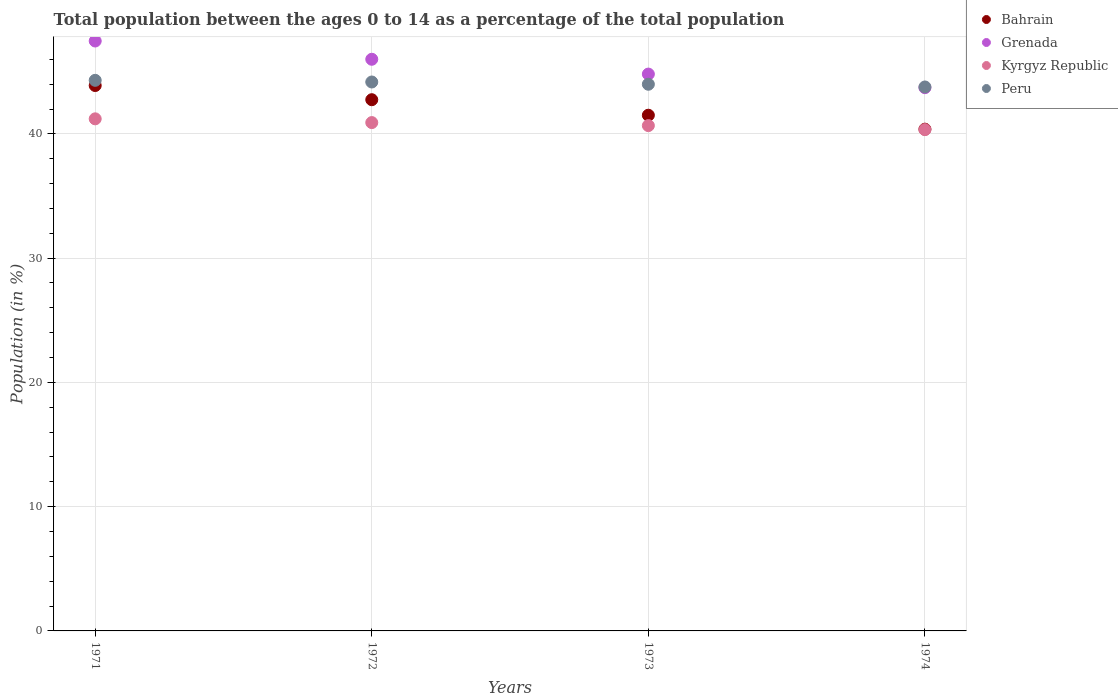Is the number of dotlines equal to the number of legend labels?
Your answer should be compact. Yes. What is the percentage of the population ages 0 to 14 in Peru in 1974?
Your response must be concise. 43.78. Across all years, what is the maximum percentage of the population ages 0 to 14 in Bahrain?
Provide a succinct answer. 43.89. Across all years, what is the minimum percentage of the population ages 0 to 14 in Kyrgyz Republic?
Your response must be concise. 40.34. In which year was the percentage of the population ages 0 to 14 in Peru maximum?
Your answer should be very brief. 1971. In which year was the percentage of the population ages 0 to 14 in Grenada minimum?
Your answer should be very brief. 1974. What is the total percentage of the population ages 0 to 14 in Kyrgyz Republic in the graph?
Ensure brevity in your answer.  163.13. What is the difference between the percentage of the population ages 0 to 14 in Bahrain in 1971 and that in 1974?
Your answer should be compact. 3.51. What is the difference between the percentage of the population ages 0 to 14 in Peru in 1972 and the percentage of the population ages 0 to 14 in Grenada in 1974?
Give a very brief answer. 0.46. What is the average percentage of the population ages 0 to 14 in Grenada per year?
Keep it short and to the point. 45.5. In the year 1972, what is the difference between the percentage of the population ages 0 to 14 in Kyrgyz Republic and percentage of the population ages 0 to 14 in Grenada?
Provide a short and direct response. -5.1. What is the ratio of the percentage of the population ages 0 to 14 in Grenada in 1972 to that in 1974?
Make the answer very short. 1.05. Is the difference between the percentage of the population ages 0 to 14 in Kyrgyz Republic in 1971 and 1973 greater than the difference between the percentage of the population ages 0 to 14 in Grenada in 1971 and 1973?
Your answer should be compact. No. What is the difference between the highest and the second highest percentage of the population ages 0 to 14 in Bahrain?
Your response must be concise. 1.14. What is the difference between the highest and the lowest percentage of the population ages 0 to 14 in Bahrain?
Offer a very short reply. 3.51. In how many years, is the percentage of the population ages 0 to 14 in Bahrain greater than the average percentage of the population ages 0 to 14 in Bahrain taken over all years?
Provide a short and direct response. 2. Is the sum of the percentage of the population ages 0 to 14 in Peru in 1971 and 1973 greater than the maximum percentage of the population ages 0 to 14 in Kyrgyz Republic across all years?
Offer a terse response. Yes. Is it the case that in every year, the sum of the percentage of the population ages 0 to 14 in Grenada and percentage of the population ages 0 to 14 in Kyrgyz Republic  is greater than the sum of percentage of the population ages 0 to 14 in Bahrain and percentage of the population ages 0 to 14 in Peru?
Your answer should be compact. No. Is it the case that in every year, the sum of the percentage of the population ages 0 to 14 in Peru and percentage of the population ages 0 to 14 in Grenada  is greater than the percentage of the population ages 0 to 14 in Bahrain?
Keep it short and to the point. Yes. How many dotlines are there?
Keep it short and to the point. 4. How many years are there in the graph?
Your response must be concise. 4. Are the values on the major ticks of Y-axis written in scientific E-notation?
Keep it short and to the point. No. Does the graph contain any zero values?
Your response must be concise. No. Does the graph contain grids?
Offer a very short reply. Yes. Where does the legend appear in the graph?
Keep it short and to the point. Top right. How many legend labels are there?
Your answer should be very brief. 4. How are the legend labels stacked?
Ensure brevity in your answer.  Vertical. What is the title of the graph?
Offer a terse response. Total population between the ages 0 to 14 as a percentage of the total population. What is the label or title of the Y-axis?
Offer a terse response. Population (in %). What is the Population (in %) of Bahrain in 1971?
Provide a succinct answer. 43.89. What is the Population (in %) in Grenada in 1971?
Your response must be concise. 47.48. What is the Population (in %) in Kyrgyz Republic in 1971?
Give a very brief answer. 41.21. What is the Population (in %) of Peru in 1971?
Your response must be concise. 44.31. What is the Population (in %) in Bahrain in 1972?
Your answer should be compact. 42.75. What is the Population (in %) in Grenada in 1972?
Keep it short and to the point. 46.01. What is the Population (in %) in Kyrgyz Republic in 1972?
Your answer should be very brief. 40.91. What is the Population (in %) of Peru in 1972?
Give a very brief answer. 44.18. What is the Population (in %) in Bahrain in 1973?
Give a very brief answer. 41.5. What is the Population (in %) of Grenada in 1973?
Provide a succinct answer. 44.81. What is the Population (in %) of Kyrgyz Republic in 1973?
Give a very brief answer. 40.67. What is the Population (in %) in Peru in 1973?
Your response must be concise. 44. What is the Population (in %) of Bahrain in 1974?
Your response must be concise. 40.38. What is the Population (in %) of Grenada in 1974?
Your answer should be very brief. 43.72. What is the Population (in %) in Kyrgyz Republic in 1974?
Ensure brevity in your answer.  40.34. What is the Population (in %) in Peru in 1974?
Your answer should be compact. 43.78. Across all years, what is the maximum Population (in %) in Bahrain?
Make the answer very short. 43.89. Across all years, what is the maximum Population (in %) of Grenada?
Ensure brevity in your answer.  47.48. Across all years, what is the maximum Population (in %) in Kyrgyz Republic?
Provide a succinct answer. 41.21. Across all years, what is the maximum Population (in %) in Peru?
Provide a succinct answer. 44.31. Across all years, what is the minimum Population (in %) in Bahrain?
Offer a terse response. 40.38. Across all years, what is the minimum Population (in %) in Grenada?
Make the answer very short. 43.72. Across all years, what is the minimum Population (in %) of Kyrgyz Republic?
Your answer should be compact. 40.34. Across all years, what is the minimum Population (in %) in Peru?
Ensure brevity in your answer.  43.78. What is the total Population (in %) of Bahrain in the graph?
Your response must be concise. 168.53. What is the total Population (in %) of Grenada in the graph?
Keep it short and to the point. 182.01. What is the total Population (in %) in Kyrgyz Republic in the graph?
Provide a short and direct response. 163.13. What is the total Population (in %) in Peru in the graph?
Your answer should be very brief. 176.26. What is the difference between the Population (in %) in Bahrain in 1971 and that in 1972?
Ensure brevity in your answer.  1.14. What is the difference between the Population (in %) in Grenada in 1971 and that in 1972?
Offer a terse response. 1.47. What is the difference between the Population (in %) in Kyrgyz Republic in 1971 and that in 1972?
Provide a short and direct response. 0.3. What is the difference between the Population (in %) of Peru in 1971 and that in 1972?
Make the answer very short. 0.13. What is the difference between the Population (in %) in Bahrain in 1971 and that in 1973?
Your answer should be compact. 2.39. What is the difference between the Population (in %) in Grenada in 1971 and that in 1973?
Provide a succinct answer. 2.66. What is the difference between the Population (in %) in Kyrgyz Republic in 1971 and that in 1973?
Keep it short and to the point. 0.54. What is the difference between the Population (in %) of Peru in 1971 and that in 1973?
Keep it short and to the point. 0.31. What is the difference between the Population (in %) in Bahrain in 1971 and that in 1974?
Provide a short and direct response. 3.51. What is the difference between the Population (in %) in Grenada in 1971 and that in 1974?
Provide a short and direct response. 3.76. What is the difference between the Population (in %) of Kyrgyz Republic in 1971 and that in 1974?
Keep it short and to the point. 0.87. What is the difference between the Population (in %) in Peru in 1971 and that in 1974?
Make the answer very short. 0.53. What is the difference between the Population (in %) of Bahrain in 1972 and that in 1973?
Give a very brief answer. 1.25. What is the difference between the Population (in %) in Grenada in 1972 and that in 1973?
Your answer should be compact. 1.19. What is the difference between the Population (in %) in Kyrgyz Republic in 1972 and that in 1973?
Offer a terse response. 0.24. What is the difference between the Population (in %) of Peru in 1972 and that in 1973?
Offer a terse response. 0.18. What is the difference between the Population (in %) in Bahrain in 1972 and that in 1974?
Keep it short and to the point. 2.37. What is the difference between the Population (in %) of Grenada in 1972 and that in 1974?
Ensure brevity in your answer.  2.29. What is the difference between the Population (in %) in Kyrgyz Republic in 1972 and that in 1974?
Give a very brief answer. 0.57. What is the difference between the Population (in %) in Peru in 1972 and that in 1974?
Provide a short and direct response. 0.4. What is the difference between the Population (in %) of Bahrain in 1973 and that in 1974?
Give a very brief answer. 1.12. What is the difference between the Population (in %) of Grenada in 1973 and that in 1974?
Provide a short and direct response. 1.09. What is the difference between the Population (in %) of Kyrgyz Republic in 1973 and that in 1974?
Your response must be concise. 0.32. What is the difference between the Population (in %) in Peru in 1973 and that in 1974?
Your answer should be compact. 0.22. What is the difference between the Population (in %) of Bahrain in 1971 and the Population (in %) of Grenada in 1972?
Your answer should be very brief. -2.11. What is the difference between the Population (in %) in Bahrain in 1971 and the Population (in %) in Kyrgyz Republic in 1972?
Keep it short and to the point. 2.98. What is the difference between the Population (in %) in Bahrain in 1971 and the Population (in %) in Peru in 1972?
Provide a succinct answer. -0.28. What is the difference between the Population (in %) of Grenada in 1971 and the Population (in %) of Kyrgyz Republic in 1972?
Give a very brief answer. 6.57. What is the difference between the Population (in %) of Grenada in 1971 and the Population (in %) of Peru in 1972?
Keep it short and to the point. 3.3. What is the difference between the Population (in %) of Kyrgyz Republic in 1971 and the Population (in %) of Peru in 1972?
Your answer should be compact. -2.96. What is the difference between the Population (in %) of Bahrain in 1971 and the Population (in %) of Grenada in 1973?
Ensure brevity in your answer.  -0.92. What is the difference between the Population (in %) in Bahrain in 1971 and the Population (in %) in Kyrgyz Republic in 1973?
Offer a terse response. 3.22. What is the difference between the Population (in %) in Bahrain in 1971 and the Population (in %) in Peru in 1973?
Offer a terse response. -0.1. What is the difference between the Population (in %) of Grenada in 1971 and the Population (in %) of Kyrgyz Republic in 1973?
Give a very brief answer. 6.81. What is the difference between the Population (in %) of Grenada in 1971 and the Population (in %) of Peru in 1973?
Your response must be concise. 3.48. What is the difference between the Population (in %) of Kyrgyz Republic in 1971 and the Population (in %) of Peru in 1973?
Offer a very short reply. -2.78. What is the difference between the Population (in %) in Bahrain in 1971 and the Population (in %) in Grenada in 1974?
Keep it short and to the point. 0.17. What is the difference between the Population (in %) of Bahrain in 1971 and the Population (in %) of Kyrgyz Republic in 1974?
Make the answer very short. 3.55. What is the difference between the Population (in %) of Bahrain in 1971 and the Population (in %) of Peru in 1974?
Give a very brief answer. 0.12. What is the difference between the Population (in %) in Grenada in 1971 and the Population (in %) in Kyrgyz Republic in 1974?
Your answer should be very brief. 7.13. What is the difference between the Population (in %) of Grenada in 1971 and the Population (in %) of Peru in 1974?
Keep it short and to the point. 3.7. What is the difference between the Population (in %) of Kyrgyz Republic in 1971 and the Population (in %) of Peru in 1974?
Ensure brevity in your answer.  -2.57. What is the difference between the Population (in %) in Bahrain in 1972 and the Population (in %) in Grenada in 1973?
Make the answer very short. -2.06. What is the difference between the Population (in %) in Bahrain in 1972 and the Population (in %) in Kyrgyz Republic in 1973?
Your answer should be compact. 2.08. What is the difference between the Population (in %) of Bahrain in 1972 and the Population (in %) of Peru in 1973?
Provide a short and direct response. -1.24. What is the difference between the Population (in %) of Grenada in 1972 and the Population (in %) of Kyrgyz Republic in 1973?
Ensure brevity in your answer.  5.34. What is the difference between the Population (in %) of Grenada in 1972 and the Population (in %) of Peru in 1973?
Offer a terse response. 2.01. What is the difference between the Population (in %) of Kyrgyz Republic in 1972 and the Population (in %) of Peru in 1973?
Your answer should be compact. -3.09. What is the difference between the Population (in %) of Bahrain in 1972 and the Population (in %) of Grenada in 1974?
Provide a succinct answer. -0.97. What is the difference between the Population (in %) of Bahrain in 1972 and the Population (in %) of Kyrgyz Republic in 1974?
Ensure brevity in your answer.  2.41. What is the difference between the Population (in %) of Bahrain in 1972 and the Population (in %) of Peru in 1974?
Offer a terse response. -1.03. What is the difference between the Population (in %) in Grenada in 1972 and the Population (in %) in Kyrgyz Republic in 1974?
Keep it short and to the point. 5.66. What is the difference between the Population (in %) in Grenada in 1972 and the Population (in %) in Peru in 1974?
Offer a terse response. 2.23. What is the difference between the Population (in %) of Kyrgyz Republic in 1972 and the Population (in %) of Peru in 1974?
Provide a short and direct response. -2.87. What is the difference between the Population (in %) in Bahrain in 1973 and the Population (in %) in Grenada in 1974?
Your answer should be very brief. -2.22. What is the difference between the Population (in %) in Bahrain in 1973 and the Population (in %) in Kyrgyz Republic in 1974?
Give a very brief answer. 1.16. What is the difference between the Population (in %) of Bahrain in 1973 and the Population (in %) of Peru in 1974?
Provide a succinct answer. -2.27. What is the difference between the Population (in %) in Grenada in 1973 and the Population (in %) in Kyrgyz Republic in 1974?
Offer a terse response. 4.47. What is the difference between the Population (in %) in Grenada in 1973 and the Population (in %) in Peru in 1974?
Offer a very short reply. 1.04. What is the difference between the Population (in %) in Kyrgyz Republic in 1973 and the Population (in %) in Peru in 1974?
Your answer should be very brief. -3.11. What is the average Population (in %) in Bahrain per year?
Give a very brief answer. 42.13. What is the average Population (in %) in Grenada per year?
Your response must be concise. 45.5. What is the average Population (in %) in Kyrgyz Republic per year?
Offer a very short reply. 40.78. What is the average Population (in %) of Peru per year?
Give a very brief answer. 44.06. In the year 1971, what is the difference between the Population (in %) of Bahrain and Population (in %) of Grenada?
Offer a very short reply. -3.58. In the year 1971, what is the difference between the Population (in %) of Bahrain and Population (in %) of Kyrgyz Republic?
Give a very brief answer. 2.68. In the year 1971, what is the difference between the Population (in %) of Bahrain and Population (in %) of Peru?
Provide a short and direct response. -0.42. In the year 1971, what is the difference between the Population (in %) of Grenada and Population (in %) of Kyrgyz Republic?
Provide a short and direct response. 6.26. In the year 1971, what is the difference between the Population (in %) in Grenada and Population (in %) in Peru?
Provide a short and direct response. 3.16. In the year 1971, what is the difference between the Population (in %) of Kyrgyz Republic and Population (in %) of Peru?
Give a very brief answer. -3.1. In the year 1972, what is the difference between the Population (in %) of Bahrain and Population (in %) of Grenada?
Make the answer very short. -3.25. In the year 1972, what is the difference between the Population (in %) of Bahrain and Population (in %) of Kyrgyz Republic?
Your response must be concise. 1.84. In the year 1972, what is the difference between the Population (in %) in Bahrain and Population (in %) in Peru?
Provide a succinct answer. -1.43. In the year 1972, what is the difference between the Population (in %) in Grenada and Population (in %) in Kyrgyz Republic?
Keep it short and to the point. 5.1. In the year 1972, what is the difference between the Population (in %) of Grenada and Population (in %) of Peru?
Offer a terse response. 1.83. In the year 1972, what is the difference between the Population (in %) in Kyrgyz Republic and Population (in %) in Peru?
Provide a succinct answer. -3.27. In the year 1973, what is the difference between the Population (in %) of Bahrain and Population (in %) of Grenada?
Ensure brevity in your answer.  -3.31. In the year 1973, what is the difference between the Population (in %) in Bahrain and Population (in %) in Kyrgyz Republic?
Offer a very short reply. 0.84. In the year 1973, what is the difference between the Population (in %) of Bahrain and Population (in %) of Peru?
Offer a terse response. -2.49. In the year 1973, what is the difference between the Population (in %) in Grenada and Population (in %) in Kyrgyz Republic?
Offer a terse response. 4.15. In the year 1973, what is the difference between the Population (in %) of Grenada and Population (in %) of Peru?
Ensure brevity in your answer.  0.82. In the year 1973, what is the difference between the Population (in %) of Kyrgyz Republic and Population (in %) of Peru?
Make the answer very short. -3.33. In the year 1974, what is the difference between the Population (in %) of Bahrain and Population (in %) of Grenada?
Keep it short and to the point. -3.34. In the year 1974, what is the difference between the Population (in %) of Bahrain and Population (in %) of Kyrgyz Republic?
Your response must be concise. 0.04. In the year 1974, what is the difference between the Population (in %) in Bahrain and Population (in %) in Peru?
Your answer should be compact. -3.4. In the year 1974, what is the difference between the Population (in %) in Grenada and Population (in %) in Kyrgyz Republic?
Keep it short and to the point. 3.38. In the year 1974, what is the difference between the Population (in %) in Grenada and Population (in %) in Peru?
Provide a short and direct response. -0.06. In the year 1974, what is the difference between the Population (in %) of Kyrgyz Republic and Population (in %) of Peru?
Provide a succinct answer. -3.43. What is the ratio of the Population (in %) of Bahrain in 1971 to that in 1972?
Ensure brevity in your answer.  1.03. What is the ratio of the Population (in %) of Grenada in 1971 to that in 1972?
Ensure brevity in your answer.  1.03. What is the ratio of the Population (in %) in Kyrgyz Republic in 1971 to that in 1972?
Your response must be concise. 1.01. What is the ratio of the Population (in %) in Bahrain in 1971 to that in 1973?
Offer a very short reply. 1.06. What is the ratio of the Population (in %) of Grenada in 1971 to that in 1973?
Your response must be concise. 1.06. What is the ratio of the Population (in %) of Kyrgyz Republic in 1971 to that in 1973?
Offer a very short reply. 1.01. What is the ratio of the Population (in %) in Bahrain in 1971 to that in 1974?
Your answer should be very brief. 1.09. What is the ratio of the Population (in %) of Grenada in 1971 to that in 1974?
Keep it short and to the point. 1.09. What is the ratio of the Population (in %) in Kyrgyz Republic in 1971 to that in 1974?
Provide a short and direct response. 1.02. What is the ratio of the Population (in %) in Peru in 1971 to that in 1974?
Offer a very short reply. 1.01. What is the ratio of the Population (in %) of Bahrain in 1972 to that in 1973?
Keep it short and to the point. 1.03. What is the ratio of the Population (in %) of Grenada in 1972 to that in 1973?
Your answer should be very brief. 1.03. What is the ratio of the Population (in %) in Kyrgyz Republic in 1972 to that in 1973?
Provide a succinct answer. 1.01. What is the ratio of the Population (in %) of Bahrain in 1972 to that in 1974?
Provide a short and direct response. 1.06. What is the ratio of the Population (in %) of Grenada in 1972 to that in 1974?
Give a very brief answer. 1.05. What is the ratio of the Population (in %) of Kyrgyz Republic in 1972 to that in 1974?
Your answer should be very brief. 1.01. What is the ratio of the Population (in %) of Peru in 1972 to that in 1974?
Offer a very short reply. 1.01. What is the ratio of the Population (in %) in Bahrain in 1973 to that in 1974?
Give a very brief answer. 1.03. What is the ratio of the Population (in %) in Grenada in 1973 to that in 1974?
Provide a short and direct response. 1.02. What is the ratio of the Population (in %) of Kyrgyz Republic in 1973 to that in 1974?
Make the answer very short. 1.01. What is the ratio of the Population (in %) of Peru in 1973 to that in 1974?
Provide a succinct answer. 1. What is the difference between the highest and the second highest Population (in %) in Bahrain?
Offer a very short reply. 1.14. What is the difference between the highest and the second highest Population (in %) of Grenada?
Offer a very short reply. 1.47. What is the difference between the highest and the second highest Population (in %) in Kyrgyz Republic?
Make the answer very short. 0.3. What is the difference between the highest and the second highest Population (in %) of Peru?
Your response must be concise. 0.13. What is the difference between the highest and the lowest Population (in %) in Bahrain?
Provide a short and direct response. 3.51. What is the difference between the highest and the lowest Population (in %) of Grenada?
Provide a succinct answer. 3.76. What is the difference between the highest and the lowest Population (in %) in Kyrgyz Republic?
Give a very brief answer. 0.87. What is the difference between the highest and the lowest Population (in %) in Peru?
Provide a succinct answer. 0.53. 